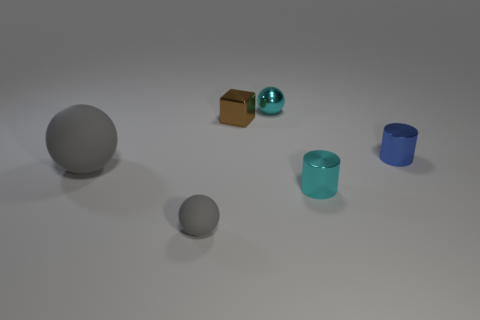If these objects represented characters in a story, what roles might they play based on their appearance? Intriguing question! The large grey sphere might represent a wise elder, stable and grounded. The small cyan shiny ball could be a youthful, vibrant character full of life and sparkle. The brown cube might symbolize a reliable, sturdy figure, perhaps a protector. The clear cyan and blue cylinders could be siblings or close companions, transparent in their intentions and complementary in their roles. 